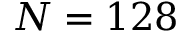Convert formula to latex. <formula><loc_0><loc_0><loc_500><loc_500>N = 1 2 8</formula> 